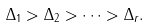<formula> <loc_0><loc_0><loc_500><loc_500>\Delta _ { 1 } > \Delta _ { 2 } > \dots > \Delta _ { r } .</formula> 